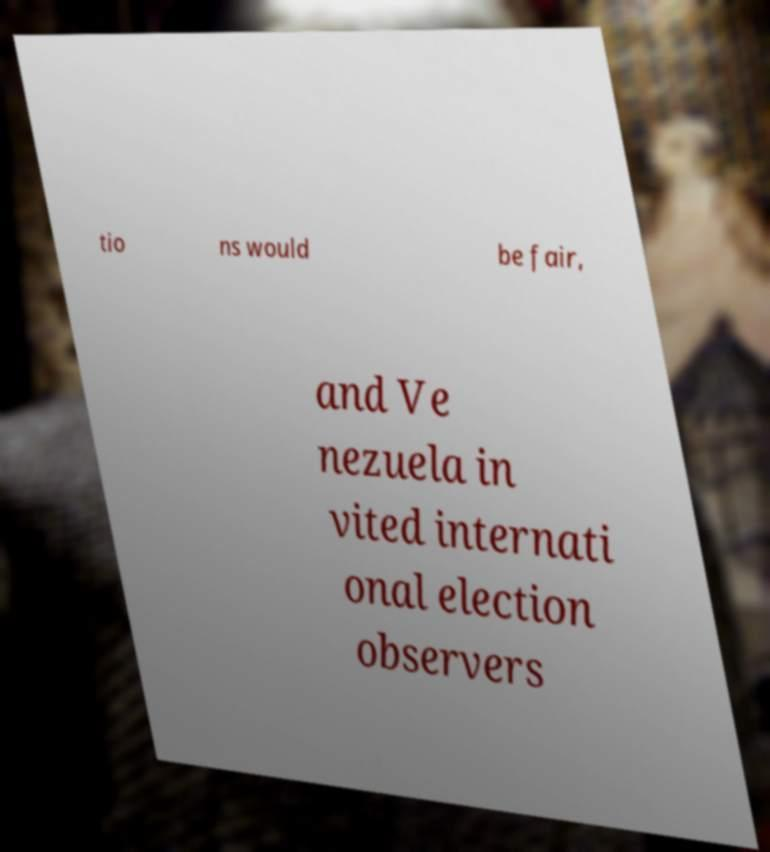Can you read and provide the text displayed in the image?This photo seems to have some interesting text. Can you extract and type it out for me? tio ns would be fair, and Ve nezuela in vited internati onal election observers 